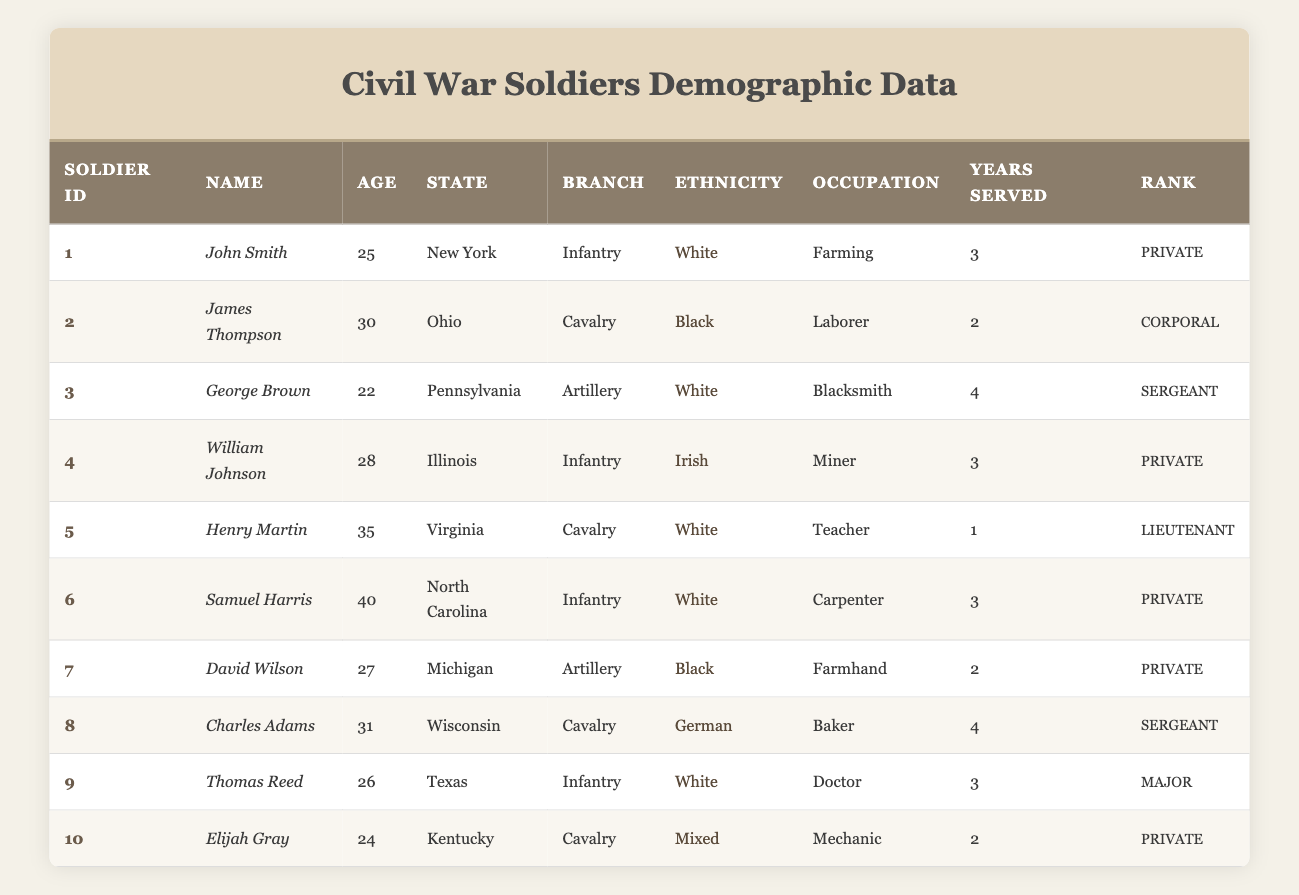What is the age of Samuel Harris? Samuel Harris is listed in the table, and his age is directly available in the "Age" column.
Answer: 40 Which soldier served in the Cavalry branch and was a teacher? Henry Martin is the only soldier in the table who served in the Cavalry and had the occupation of a teacher.
Answer: Henry Martin How many soldiers served for more than 3 years? We check the "Years Served" column for each soldier: John Smith, George Brown, William Johnson, Charles Adams, and Thomas Reed all served for 3 or more years. Therefore, a total of 5 soldiers served for more than 3 years.
Answer: 5 Is any soldier from Texas in the Infantry branch? The table indicates that Thomas Reed is from Texas, and he served in the Infantry branch. Therefore, the statement is true.
Answer: Yes Who is the youngest soldier and how old is he? By examining the "Age" column, we find George Brown, who is 22 years old, is the youngest soldier in the table.
Answer: 22 Which ethnicity has the most representation among the soldiers? Analyzing the "Ethnicity" column, we see there are four White soldiers, two Black soldiers, one Irish, one German, and one Mixed. White is the ethnicity with the most representation.
Answer: White If we sum the ages of all the soldiers, what is the total? The ages listed are: 25 + 30 + 22 + 28 + 35 + 40 + 27 + 31 + 26 + 24, which equals  24. Calculating that gives 25 + 30 = 55, 55 + 22 = 77, 77 + 28 = 105, 105 + 35 = 140, 140 + 40 = 180, 180 + 27 = 207, 207 + 31 = 238, 238 + 26 = 264, 264 + 24 = 288. Thus, the total is 288.
Answer: 288 How many soldiers are from the state of Ohio? There is only one soldier, James Thompson, listed under the state of Ohio in the "State" column.
Answer: 1 Which soldier has the highest rank and what is that rank? The highest rank in the table is Major, which belongs to Thomas Reed.
Answer: Major 